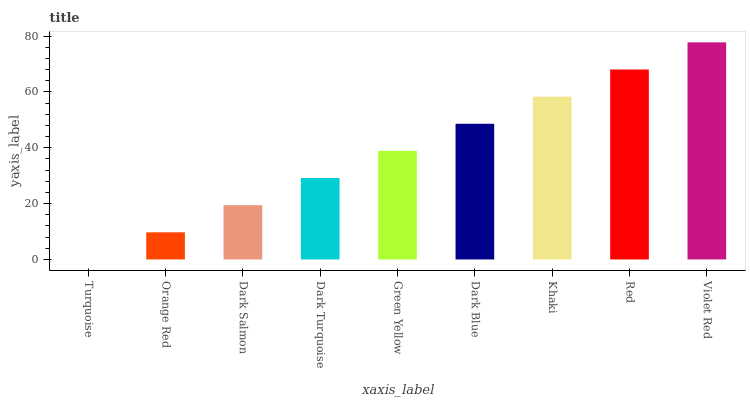Is Turquoise the minimum?
Answer yes or no. Yes. Is Violet Red the maximum?
Answer yes or no. Yes. Is Orange Red the minimum?
Answer yes or no. No. Is Orange Red the maximum?
Answer yes or no. No. Is Orange Red greater than Turquoise?
Answer yes or no. Yes. Is Turquoise less than Orange Red?
Answer yes or no. Yes. Is Turquoise greater than Orange Red?
Answer yes or no. No. Is Orange Red less than Turquoise?
Answer yes or no. No. Is Green Yellow the high median?
Answer yes or no. Yes. Is Green Yellow the low median?
Answer yes or no. Yes. Is Dark Salmon the high median?
Answer yes or no. No. Is Violet Red the low median?
Answer yes or no. No. 